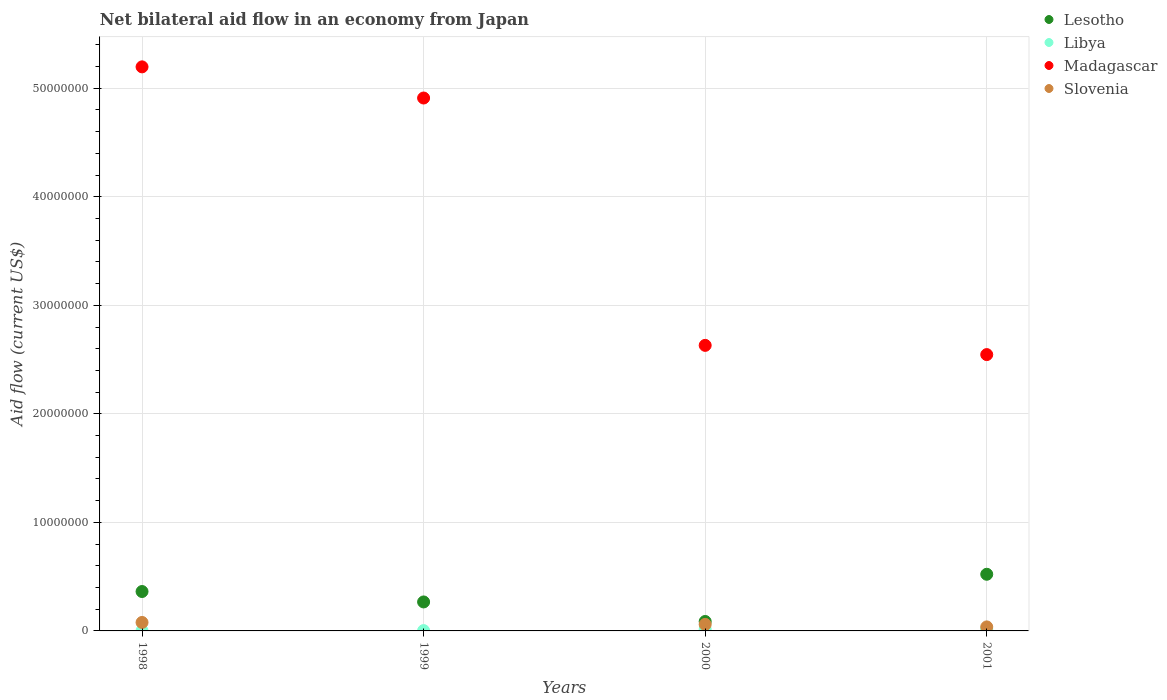How many different coloured dotlines are there?
Ensure brevity in your answer.  4. What is the net bilateral aid flow in Lesotho in 2001?
Provide a short and direct response. 5.22e+06. Across all years, what is the minimum net bilateral aid flow in Lesotho?
Provide a succinct answer. 8.70e+05. In which year was the net bilateral aid flow in Libya maximum?
Provide a succinct answer. 2001. What is the total net bilateral aid flow in Lesotho in the graph?
Give a very brief answer. 1.24e+07. What is the difference between the net bilateral aid flow in Libya in 1999 and that in 2000?
Make the answer very short. -1.20e+05. What is the difference between the net bilateral aid flow in Libya in 1998 and the net bilateral aid flow in Lesotho in 2001?
Offer a very short reply. -5.20e+06. What is the average net bilateral aid flow in Lesotho per year?
Ensure brevity in your answer.  3.10e+06. In the year 2000, what is the difference between the net bilateral aid flow in Madagascar and net bilateral aid flow in Libya?
Provide a short and direct response. 2.62e+07. In how many years, is the net bilateral aid flow in Madagascar greater than 4000000 US$?
Give a very brief answer. 4. What is the ratio of the net bilateral aid flow in Libya in 1998 to that in 2001?
Offer a very short reply. 0.12. What is the difference between the highest and the second highest net bilateral aid flow in Lesotho?
Your response must be concise. 1.59e+06. Is the sum of the net bilateral aid flow in Libya in 1998 and 1999 greater than the maximum net bilateral aid flow in Slovenia across all years?
Offer a very short reply. No. Is it the case that in every year, the sum of the net bilateral aid flow in Libya and net bilateral aid flow in Madagascar  is greater than the sum of net bilateral aid flow in Lesotho and net bilateral aid flow in Slovenia?
Your response must be concise. Yes. Is the net bilateral aid flow in Slovenia strictly greater than the net bilateral aid flow in Madagascar over the years?
Offer a very short reply. No. Is the net bilateral aid flow in Madagascar strictly less than the net bilateral aid flow in Libya over the years?
Your answer should be compact. No. What is the difference between two consecutive major ticks on the Y-axis?
Provide a succinct answer. 1.00e+07. Does the graph contain grids?
Provide a short and direct response. Yes. What is the title of the graph?
Your response must be concise. Net bilateral aid flow in an economy from Japan. Does "Croatia" appear as one of the legend labels in the graph?
Provide a succinct answer. No. What is the label or title of the X-axis?
Offer a very short reply. Years. What is the label or title of the Y-axis?
Your answer should be compact. Aid flow (current US$). What is the Aid flow (current US$) of Lesotho in 1998?
Offer a terse response. 3.63e+06. What is the Aid flow (current US$) of Madagascar in 1998?
Make the answer very short. 5.20e+07. What is the Aid flow (current US$) of Slovenia in 1998?
Keep it short and to the point. 7.80e+05. What is the Aid flow (current US$) in Lesotho in 1999?
Provide a short and direct response. 2.67e+06. What is the Aid flow (current US$) of Libya in 1999?
Offer a very short reply. 3.00e+04. What is the Aid flow (current US$) of Madagascar in 1999?
Keep it short and to the point. 4.91e+07. What is the Aid flow (current US$) in Slovenia in 1999?
Your answer should be compact. 0. What is the Aid flow (current US$) of Lesotho in 2000?
Give a very brief answer. 8.70e+05. What is the Aid flow (current US$) of Libya in 2000?
Offer a very short reply. 1.50e+05. What is the Aid flow (current US$) in Madagascar in 2000?
Make the answer very short. 2.63e+07. What is the Aid flow (current US$) of Lesotho in 2001?
Give a very brief answer. 5.22e+06. What is the Aid flow (current US$) of Libya in 2001?
Give a very brief answer. 1.70e+05. What is the Aid flow (current US$) of Madagascar in 2001?
Your answer should be compact. 2.55e+07. Across all years, what is the maximum Aid flow (current US$) of Lesotho?
Offer a terse response. 5.22e+06. Across all years, what is the maximum Aid flow (current US$) of Libya?
Ensure brevity in your answer.  1.70e+05. Across all years, what is the maximum Aid flow (current US$) of Madagascar?
Your response must be concise. 5.20e+07. Across all years, what is the maximum Aid flow (current US$) of Slovenia?
Your answer should be very brief. 7.80e+05. Across all years, what is the minimum Aid flow (current US$) of Lesotho?
Your answer should be very brief. 8.70e+05. Across all years, what is the minimum Aid flow (current US$) in Madagascar?
Provide a short and direct response. 2.55e+07. What is the total Aid flow (current US$) in Lesotho in the graph?
Ensure brevity in your answer.  1.24e+07. What is the total Aid flow (current US$) in Madagascar in the graph?
Offer a terse response. 1.53e+08. What is the total Aid flow (current US$) of Slovenia in the graph?
Keep it short and to the point. 1.75e+06. What is the difference between the Aid flow (current US$) of Lesotho in 1998 and that in 1999?
Provide a succinct answer. 9.60e+05. What is the difference between the Aid flow (current US$) in Libya in 1998 and that in 1999?
Offer a terse response. -10000. What is the difference between the Aid flow (current US$) in Madagascar in 1998 and that in 1999?
Keep it short and to the point. 2.87e+06. What is the difference between the Aid flow (current US$) of Lesotho in 1998 and that in 2000?
Offer a terse response. 2.76e+06. What is the difference between the Aid flow (current US$) of Madagascar in 1998 and that in 2000?
Make the answer very short. 2.57e+07. What is the difference between the Aid flow (current US$) in Lesotho in 1998 and that in 2001?
Ensure brevity in your answer.  -1.59e+06. What is the difference between the Aid flow (current US$) in Libya in 1998 and that in 2001?
Your answer should be compact. -1.50e+05. What is the difference between the Aid flow (current US$) of Madagascar in 1998 and that in 2001?
Provide a short and direct response. 2.65e+07. What is the difference between the Aid flow (current US$) in Slovenia in 1998 and that in 2001?
Ensure brevity in your answer.  4.10e+05. What is the difference between the Aid flow (current US$) of Lesotho in 1999 and that in 2000?
Offer a very short reply. 1.80e+06. What is the difference between the Aid flow (current US$) of Madagascar in 1999 and that in 2000?
Make the answer very short. 2.28e+07. What is the difference between the Aid flow (current US$) of Lesotho in 1999 and that in 2001?
Offer a terse response. -2.55e+06. What is the difference between the Aid flow (current US$) in Libya in 1999 and that in 2001?
Ensure brevity in your answer.  -1.40e+05. What is the difference between the Aid flow (current US$) in Madagascar in 1999 and that in 2001?
Make the answer very short. 2.36e+07. What is the difference between the Aid flow (current US$) of Lesotho in 2000 and that in 2001?
Offer a terse response. -4.35e+06. What is the difference between the Aid flow (current US$) of Madagascar in 2000 and that in 2001?
Provide a short and direct response. 8.50e+05. What is the difference between the Aid flow (current US$) of Slovenia in 2000 and that in 2001?
Provide a succinct answer. 2.30e+05. What is the difference between the Aid flow (current US$) in Lesotho in 1998 and the Aid flow (current US$) in Libya in 1999?
Make the answer very short. 3.60e+06. What is the difference between the Aid flow (current US$) of Lesotho in 1998 and the Aid flow (current US$) of Madagascar in 1999?
Make the answer very short. -4.55e+07. What is the difference between the Aid flow (current US$) of Libya in 1998 and the Aid flow (current US$) of Madagascar in 1999?
Offer a very short reply. -4.91e+07. What is the difference between the Aid flow (current US$) in Lesotho in 1998 and the Aid flow (current US$) in Libya in 2000?
Give a very brief answer. 3.48e+06. What is the difference between the Aid flow (current US$) in Lesotho in 1998 and the Aid flow (current US$) in Madagascar in 2000?
Provide a succinct answer. -2.27e+07. What is the difference between the Aid flow (current US$) of Lesotho in 1998 and the Aid flow (current US$) of Slovenia in 2000?
Offer a very short reply. 3.03e+06. What is the difference between the Aid flow (current US$) of Libya in 1998 and the Aid flow (current US$) of Madagascar in 2000?
Your answer should be very brief. -2.63e+07. What is the difference between the Aid flow (current US$) in Libya in 1998 and the Aid flow (current US$) in Slovenia in 2000?
Provide a short and direct response. -5.80e+05. What is the difference between the Aid flow (current US$) of Madagascar in 1998 and the Aid flow (current US$) of Slovenia in 2000?
Give a very brief answer. 5.14e+07. What is the difference between the Aid flow (current US$) in Lesotho in 1998 and the Aid flow (current US$) in Libya in 2001?
Offer a terse response. 3.46e+06. What is the difference between the Aid flow (current US$) in Lesotho in 1998 and the Aid flow (current US$) in Madagascar in 2001?
Offer a very short reply. -2.18e+07. What is the difference between the Aid flow (current US$) of Lesotho in 1998 and the Aid flow (current US$) of Slovenia in 2001?
Offer a terse response. 3.26e+06. What is the difference between the Aid flow (current US$) in Libya in 1998 and the Aid flow (current US$) in Madagascar in 2001?
Give a very brief answer. -2.54e+07. What is the difference between the Aid flow (current US$) in Libya in 1998 and the Aid flow (current US$) in Slovenia in 2001?
Offer a very short reply. -3.50e+05. What is the difference between the Aid flow (current US$) in Madagascar in 1998 and the Aid flow (current US$) in Slovenia in 2001?
Provide a succinct answer. 5.16e+07. What is the difference between the Aid flow (current US$) of Lesotho in 1999 and the Aid flow (current US$) of Libya in 2000?
Offer a terse response. 2.52e+06. What is the difference between the Aid flow (current US$) in Lesotho in 1999 and the Aid flow (current US$) in Madagascar in 2000?
Your response must be concise. -2.36e+07. What is the difference between the Aid flow (current US$) of Lesotho in 1999 and the Aid flow (current US$) of Slovenia in 2000?
Make the answer very short. 2.07e+06. What is the difference between the Aid flow (current US$) of Libya in 1999 and the Aid flow (current US$) of Madagascar in 2000?
Your answer should be very brief. -2.63e+07. What is the difference between the Aid flow (current US$) in Libya in 1999 and the Aid flow (current US$) in Slovenia in 2000?
Keep it short and to the point. -5.70e+05. What is the difference between the Aid flow (current US$) of Madagascar in 1999 and the Aid flow (current US$) of Slovenia in 2000?
Ensure brevity in your answer.  4.85e+07. What is the difference between the Aid flow (current US$) of Lesotho in 1999 and the Aid flow (current US$) of Libya in 2001?
Make the answer very short. 2.50e+06. What is the difference between the Aid flow (current US$) of Lesotho in 1999 and the Aid flow (current US$) of Madagascar in 2001?
Provide a succinct answer. -2.28e+07. What is the difference between the Aid flow (current US$) of Lesotho in 1999 and the Aid flow (current US$) of Slovenia in 2001?
Your response must be concise. 2.30e+06. What is the difference between the Aid flow (current US$) of Libya in 1999 and the Aid flow (current US$) of Madagascar in 2001?
Your response must be concise. -2.54e+07. What is the difference between the Aid flow (current US$) of Libya in 1999 and the Aid flow (current US$) of Slovenia in 2001?
Your answer should be compact. -3.40e+05. What is the difference between the Aid flow (current US$) in Madagascar in 1999 and the Aid flow (current US$) in Slovenia in 2001?
Keep it short and to the point. 4.87e+07. What is the difference between the Aid flow (current US$) of Lesotho in 2000 and the Aid flow (current US$) of Libya in 2001?
Ensure brevity in your answer.  7.00e+05. What is the difference between the Aid flow (current US$) of Lesotho in 2000 and the Aid flow (current US$) of Madagascar in 2001?
Give a very brief answer. -2.46e+07. What is the difference between the Aid flow (current US$) in Lesotho in 2000 and the Aid flow (current US$) in Slovenia in 2001?
Provide a succinct answer. 5.00e+05. What is the difference between the Aid flow (current US$) of Libya in 2000 and the Aid flow (current US$) of Madagascar in 2001?
Make the answer very short. -2.53e+07. What is the difference between the Aid flow (current US$) in Madagascar in 2000 and the Aid flow (current US$) in Slovenia in 2001?
Provide a succinct answer. 2.59e+07. What is the average Aid flow (current US$) in Lesotho per year?
Make the answer very short. 3.10e+06. What is the average Aid flow (current US$) of Libya per year?
Make the answer very short. 9.25e+04. What is the average Aid flow (current US$) in Madagascar per year?
Your answer should be very brief. 3.82e+07. What is the average Aid flow (current US$) of Slovenia per year?
Keep it short and to the point. 4.38e+05. In the year 1998, what is the difference between the Aid flow (current US$) of Lesotho and Aid flow (current US$) of Libya?
Make the answer very short. 3.61e+06. In the year 1998, what is the difference between the Aid flow (current US$) in Lesotho and Aid flow (current US$) in Madagascar?
Give a very brief answer. -4.83e+07. In the year 1998, what is the difference between the Aid flow (current US$) in Lesotho and Aid flow (current US$) in Slovenia?
Keep it short and to the point. 2.85e+06. In the year 1998, what is the difference between the Aid flow (current US$) in Libya and Aid flow (current US$) in Madagascar?
Provide a succinct answer. -5.20e+07. In the year 1998, what is the difference between the Aid flow (current US$) in Libya and Aid flow (current US$) in Slovenia?
Give a very brief answer. -7.60e+05. In the year 1998, what is the difference between the Aid flow (current US$) in Madagascar and Aid flow (current US$) in Slovenia?
Provide a succinct answer. 5.12e+07. In the year 1999, what is the difference between the Aid flow (current US$) in Lesotho and Aid flow (current US$) in Libya?
Make the answer very short. 2.64e+06. In the year 1999, what is the difference between the Aid flow (current US$) of Lesotho and Aid flow (current US$) of Madagascar?
Your answer should be compact. -4.64e+07. In the year 1999, what is the difference between the Aid flow (current US$) of Libya and Aid flow (current US$) of Madagascar?
Ensure brevity in your answer.  -4.91e+07. In the year 2000, what is the difference between the Aid flow (current US$) of Lesotho and Aid flow (current US$) of Libya?
Give a very brief answer. 7.20e+05. In the year 2000, what is the difference between the Aid flow (current US$) in Lesotho and Aid flow (current US$) in Madagascar?
Your response must be concise. -2.54e+07. In the year 2000, what is the difference between the Aid flow (current US$) of Libya and Aid flow (current US$) of Madagascar?
Offer a terse response. -2.62e+07. In the year 2000, what is the difference between the Aid flow (current US$) in Libya and Aid flow (current US$) in Slovenia?
Your answer should be very brief. -4.50e+05. In the year 2000, what is the difference between the Aid flow (current US$) of Madagascar and Aid flow (current US$) of Slovenia?
Offer a very short reply. 2.57e+07. In the year 2001, what is the difference between the Aid flow (current US$) of Lesotho and Aid flow (current US$) of Libya?
Ensure brevity in your answer.  5.05e+06. In the year 2001, what is the difference between the Aid flow (current US$) of Lesotho and Aid flow (current US$) of Madagascar?
Keep it short and to the point. -2.02e+07. In the year 2001, what is the difference between the Aid flow (current US$) in Lesotho and Aid flow (current US$) in Slovenia?
Offer a very short reply. 4.85e+06. In the year 2001, what is the difference between the Aid flow (current US$) in Libya and Aid flow (current US$) in Madagascar?
Make the answer very short. -2.53e+07. In the year 2001, what is the difference between the Aid flow (current US$) of Libya and Aid flow (current US$) of Slovenia?
Your response must be concise. -2.00e+05. In the year 2001, what is the difference between the Aid flow (current US$) of Madagascar and Aid flow (current US$) of Slovenia?
Your answer should be compact. 2.51e+07. What is the ratio of the Aid flow (current US$) in Lesotho in 1998 to that in 1999?
Your response must be concise. 1.36. What is the ratio of the Aid flow (current US$) in Libya in 1998 to that in 1999?
Your response must be concise. 0.67. What is the ratio of the Aid flow (current US$) in Madagascar in 1998 to that in 1999?
Offer a terse response. 1.06. What is the ratio of the Aid flow (current US$) of Lesotho in 1998 to that in 2000?
Offer a very short reply. 4.17. What is the ratio of the Aid flow (current US$) of Libya in 1998 to that in 2000?
Your answer should be very brief. 0.13. What is the ratio of the Aid flow (current US$) of Madagascar in 1998 to that in 2000?
Give a very brief answer. 1.98. What is the ratio of the Aid flow (current US$) of Lesotho in 1998 to that in 2001?
Make the answer very short. 0.7. What is the ratio of the Aid flow (current US$) of Libya in 1998 to that in 2001?
Make the answer very short. 0.12. What is the ratio of the Aid flow (current US$) of Madagascar in 1998 to that in 2001?
Ensure brevity in your answer.  2.04. What is the ratio of the Aid flow (current US$) of Slovenia in 1998 to that in 2001?
Make the answer very short. 2.11. What is the ratio of the Aid flow (current US$) in Lesotho in 1999 to that in 2000?
Keep it short and to the point. 3.07. What is the ratio of the Aid flow (current US$) in Madagascar in 1999 to that in 2000?
Make the answer very short. 1.87. What is the ratio of the Aid flow (current US$) of Lesotho in 1999 to that in 2001?
Provide a short and direct response. 0.51. What is the ratio of the Aid flow (current US$) in Libya in 1999 to that in 2001?
Offer a terse response. 0.18. What is the ratio of the Aid flow (current US$) of Madagascar in 1999 to that in 2001?
Provide a short and direct response. 1.93. What is the ratio of the Aid flow (current US$) in Libya in 2000 to that in 2001?
Provide a short and direct response. 0.88. What is the ratio of the Aid flow (current US$) of Madagascar in 2000 to that in 2001?
Provide a short and direct response. 1.03. What is the ratio of the Aid flow (current US$) of Slovenia in 2000 to that in 2001?
Give a very brief answer. 1.62. What is the difference between the highest and the second highest Aid flow (current US$) in Lesotho?
Your response must be concise. 1.59e+06. What is the difference between the highest and the second highest Aid flow (current US$) in Madagascar?
Your response must be concise. 2.87e+06. What is the difference between the highest and the lowest Aid flow (current US$) in Lesotho?
Your answer should be very brief. 4.35e+06. What is the difference between the highest and the lowest Aid flow (current US$) in Libya?
Provide a succinct answer. 1.50e+05. What is the difference between the highest and the lowest Aid flow (current US$) of Madagascar?
Offer a very short reply. 2.65e+07. What is the difference between the highest and the lowest Aid flow (current US$) of Slovenia?
Provide a succinct answer. 7.80e+05. 